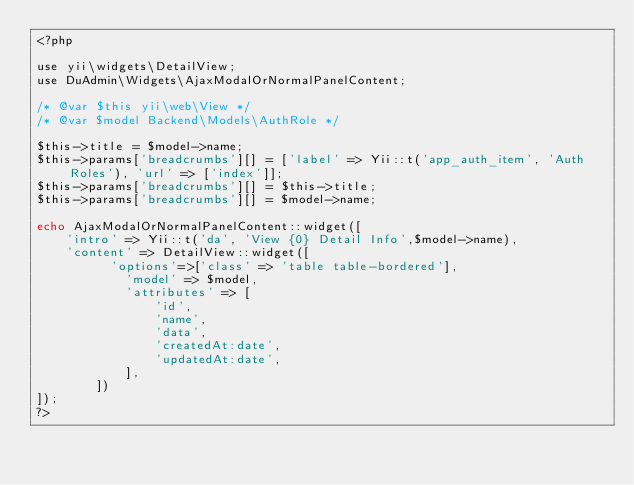Convert code to text. <code><loc_0><loc_0><loc_500><loc_500><_PHP_><?php

use yii\widgets\DetailView;
use DuAdmin\Widgets\AjaxModalOrNormalPanelContent;

/* @var $this yii\web\View */
/* @var $model Backend\Models\AuthRole */

$this->title = $model->name;
$this->params['breadcrumbs'][] = ['label' => Yii::t('app_auth_item', 'Auth Roles'), 'url' => ['index']];
$this->params['breadcrumbs'][] = $this->title;
$this->params['breadcrumbs'][] = $model->name;

echo AjaxModalOrNormalPanelContent::widget([
    'intro' => Yii::t('da', 'View {0} Detail Info',$model->name),
    'content' => DetailView::widget([
        	'options'=>['class' => 'table table-bordered'],
            'model' => $model,
            'attributes' => [
                'id',
                'name',
                'data',
                'createdAt:date',
                'updatedAt:date',
            ],
        ])
]);
?>
</code> 